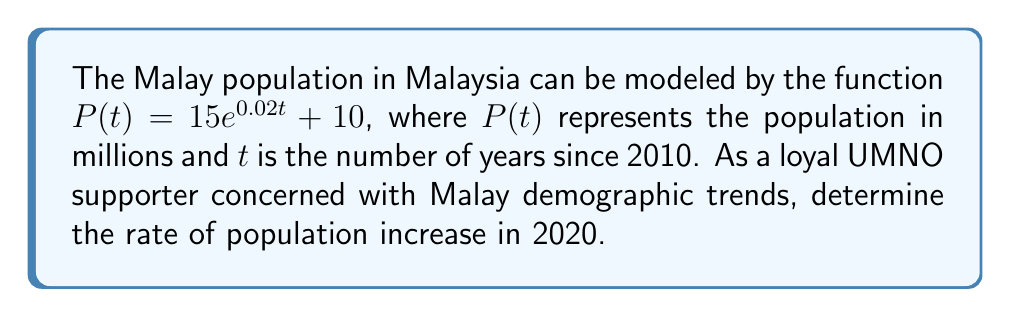Can you answer this question? To find the rate of population increase in 2020, we need to calculate the derivative of $P(t)$ and evaluate it at $t = 10$ (since 2020 is 10 years after 2010).

Step 1: Find the derivative of $P(t)$
$$\frac{d}{dt}P(t) = \frac{d}{dt}(15e^{0.02t} + 10)$$
$$P'(t) = 15 \cdot 0.02e^{0.02t} = 0.3e^{0.02t}$$

Step 2: Evaluate $P'(t)$ at $t = 10$
$$P'(10) = 0.3e^{0.02(10)}$$
$$P'(10) = 0.3e^{0.2}$$
$$P'(10) \approx 0.3660$$

Step 3: Interpret the result
The rate of population increase in 2020 is approximately 0.3660 million people per year.

This represents the slope of the tangent line to the population curve at $t = 10$, which is crucial for UMNO's demographic planning and policy-making.
Answer: $0.3660$ million/year 